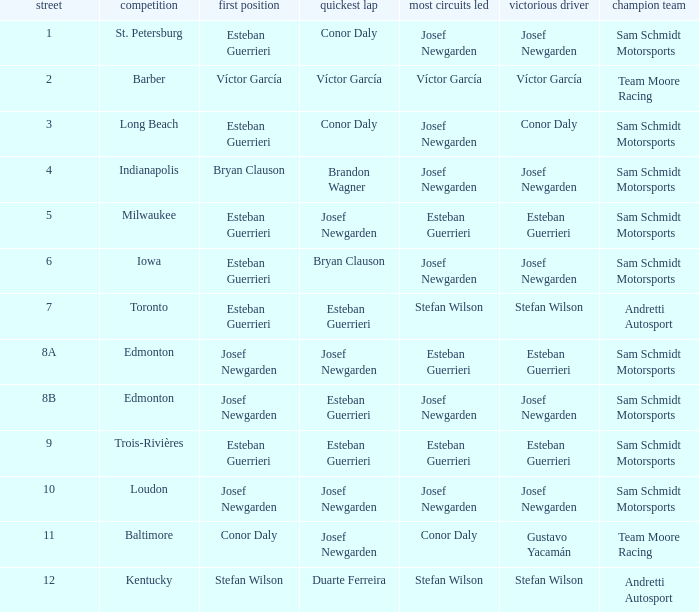Who had the fastest lap(s) when josef newgarden led the most laps at edmonton? Esteban Guerrieri. 